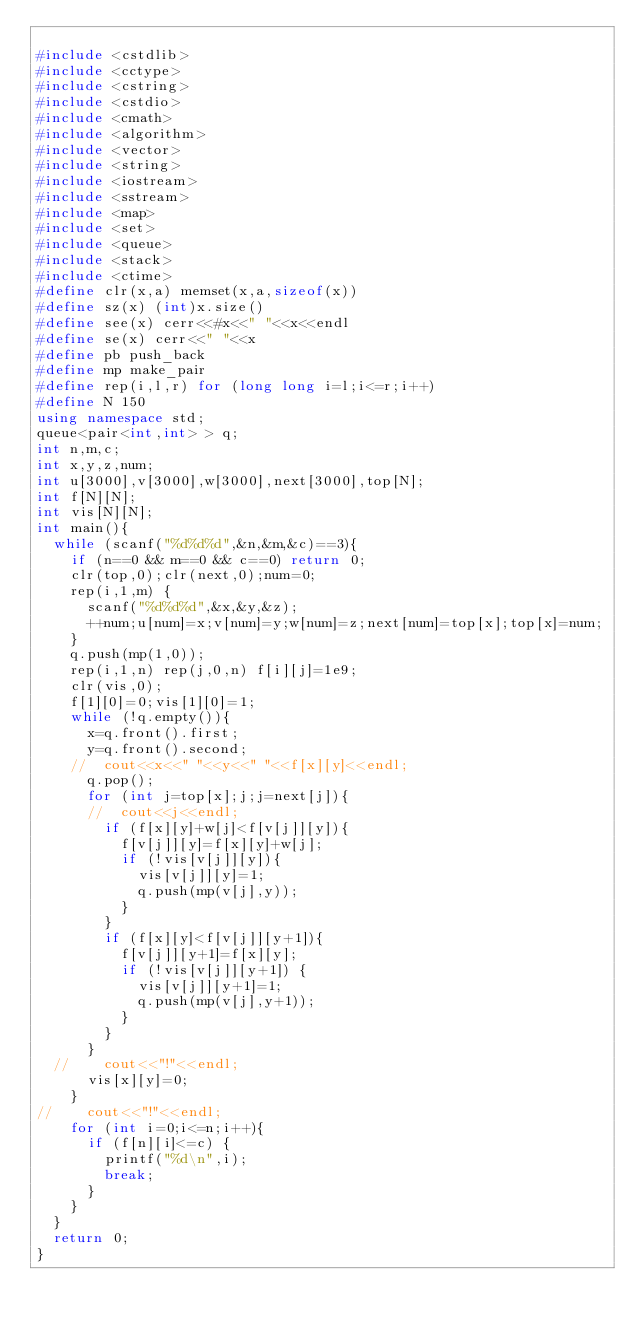Convert code to text. <code><loc_0><loc_0><loc_500><loc_500><_C++_>
#include <cstdlib>
#include <cctype>
#include <cstring>
#include <cstdio>
#include <cmath>
#include <algorithm>
#include <vector>
#include <string>
#include <iostream>
#include <sstream>
#include <map>
#include <set>
#include <queue>
#include <stack>
#include <ctime>
#define clr(x,a) memset(x,a,sizeof(x))
#define sz(x) (int)x.size()
#define see(x) cerr<<#x<<" "<<x<<endl
#define se(x) cerr<<" "<<x 
#define pb push_back
#define mp make_pair
#define rep(i,l,r) for (long long i=l;i<=r;i++)
#define N 150
using namespace std;
queue<pair<int,int> > q;
int n,m,c;
int x,y,z,num;
int u[3000],v[3000],w[3000],next[3000],top[N];
int f[N][N];
int vis[N][N];
int main(){
	while (scanf("%d%d%d",&n,&m,&c)==3){
		if (n==0 && m==0 && c==0) return 0;
		clr(top,0);clr(next,0);num=0;
		rep(i,1,m) {
			scanf("%d%d%d",&x,&y,&z);
			++num;u[num]=x;v[num]=y;w[num]=z;next[num]=top[x];top[x]=num;
		}
		q.push(mp(1,0));
		rep(i,1,n) rep(j,0,n) f[i][j]=1e9;
		clr(vis,0);
		f[1][0]=0;vis[1][0]=1;
		while (!q.empty()){
			x=q.front().first;
			y=q.front().second;
		//	cout<<x<<" "<<y<<" "<<f[x][y]<<endl;
			q.pop();
			for (int j=top[x];j;j=next[j]){
			//	cout<<j<<endl;
				if (f[x][y]+w[j]<f[v[j]][y]){
					f[v[j]][y]=f[x][y]+w[j];
					if (!vis[v[j]][y]){
						vis[v[j]][y]=1;
						q.push(mp(v[j],y));
					}	
				}
				if (f[x][y]<f[v[j]][y+1]){
					f[v[j]][y+1]=f[x][y];
					if (!vis[v[j]][y+1]) {
						vis[v[j]][y+1]=1;
						q.push(mp(v[j],y+1));
					}
				}
			}
	//		cout<<"!"<<endl;
			vis[x][y]=0;
		}
//		cout<<"!"<<endl;
		for (int i=0;i<=n;i++){
			if (f[n][i]<=c) {
				printf("%d\n",i);
				break;
			}
		}
	}
	return 0;
}</code> 